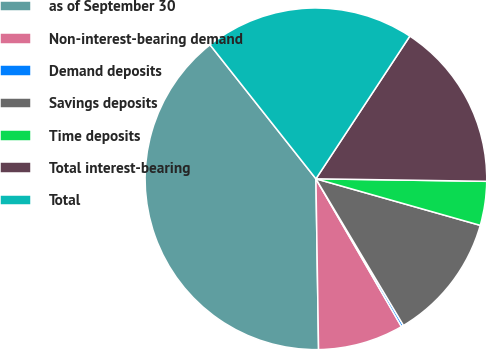Convert chart to OTSL. <chart><loc_0><loc_0><loc_500><loc_500><pie_chart><fcel>as of September 30<fcel>Non-interest-bearing demand<fcel>Demand deposits<fcel>Savings deposits<fcel>Time deposits<fcel>Total interest-bearing<fcel>Total<nl><fcel>39.6%<fcel>8.1%<fcel>0.22%<fcel>12.04%<fcel>4.16%<fcel>15.97%<fcel>19.91%<nl></chart> 